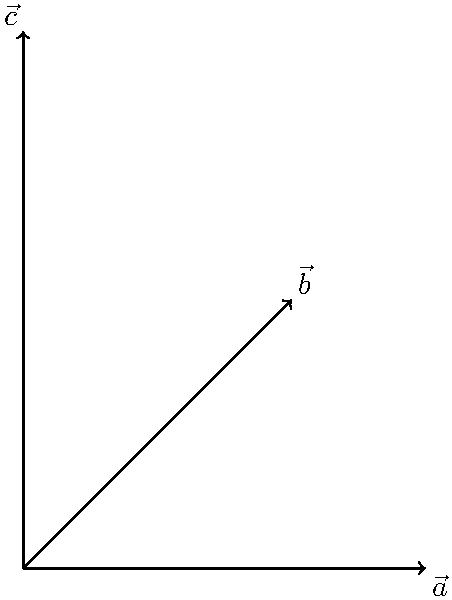Imagine you're explaining vector magnitudes to your students using arrows of different lengths. In the diagram above, three vectors $\vec{a}$, $\vec{b}$, and $\vec{c}$ are shown. Without using calculations, how would you arrange these vectors in order of increasing magnitude? Use the analogy of comparing the lengths of different paths to help your students understand the concept. Let's approach this step-by-step using the analogy of comparing paths:

1. Imagine each vector as a path from the origin (starting point) to its arrowhead (ending point).

2. $\vec{a}$ is like a straight path along the ground. It's the shortest route between two points.

3. $\vec{b}$ is like a diagonal path up a hill. It's longer than $\vec{a}$ because it goes both horizontally and vertically.

4. $\vec{c}$ is like climbing straight up a steep cliff. It's clearly the longest path among the three.

5. Visually comparing the lengths of these paths, we can see that $\vec{a}$ is the shortest, $\vec{b}$ is longer than $\vec{a}$ but shorter than $\vec{c}$, and $\vec{c}$ is the longest.

6. The magnitude of a vector is directly related to its length. Longer vectors have greater magnitudes.

Therefore, arranging the vectors in order of increasing magnitude is equivalent to arranging them in order of increasing length: $\vec{a}$, $\vec{b}$, $\vec{c}$.
Answer: $\|\vec{a}\| < \|\vec{b}\| < \|\vec{c}\|$ 